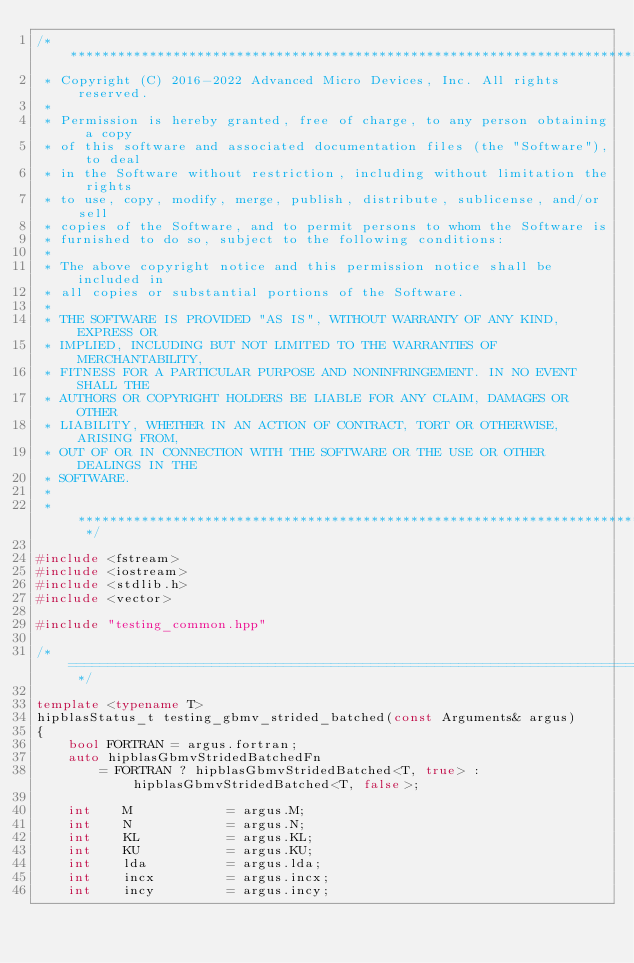<code> <loc_0><loc_0><loc_500><loc_500><_C++_>/* ************************************************************************
 * Copyright (C) 2016-2022 Advanced Micro Devices, Inc. All rights reserved.
 *
 * Permission is hereby granted, free of charge, to any person obtaining a copy
 * of this software and associated documentation files (the "Software"), to deal
 * in the Software without restriction, including without limitation the rights
 * to use, copy, modify, merge, publish, distribute, sublicense, and/or sell
 * copies of the Software, and to permit persons to whom the Software is
 * furnished to do so, subject to the following conditions:
 *
 * The above copyright notice and this permission notice shall be included in
 * all copies or substantial portions of the Software.
 *
 * THE SOFTWARE IS PROVIDED "AS IS", WITHOUT WARRANTY OF ANY KIND, EXPRESS OR
 * IMPLIED, INCLUDING BUT NOT LIMITED TO THE WARRANTIES OF MERCHANTABILITY,
 * FITNESS FOR A PARTICULAR PURPOSE AND NONINFRINGEMENT. IN NO EVENT SHALL THE
 * AUTHORS OR COPYRIGHT HOLDERS BE LIABLE FOR ANY CLAIM, DAMAGES OR OTHER
 * LIABILITY, WHETHER IN AN ACTION OF CONTRACT, TORT OR OTHERWISE, ARISING FROM,
 * OUT OF OR IN CONNECTION WITH THE SOFTWARE OR THE USE OR OTHER DEALINGS IN THE
 * SOFTWARE.
 *
 * ************************************************************************ */

#include <fstream>
#include <iostream>
#include <stdlib.h>
#include <vector>

#include "testing_common.hpp"

/* ============================================================================================ */

template <typename T>
hipblasStatus_t testing_gbmv_strided_batched(const Arguments& argus)
{
    bool FORTRAN = argus.fortran;
    auto hipblasGbmvStridedBatchedFn
        = FORTRAN ? hipblasGbmvStridedBatched<T, true> : hipblasGbmvStridedBatched<T, false>;

    int    M            = argus.M;
    int    N            = argus.N;
    int    KL           = argus.KL;
    int    KU           = argus.KU;
    int    lda          = argus.lda;
    int    incx         = argus.incx;
    int    incy         = argus.incy;</code> 